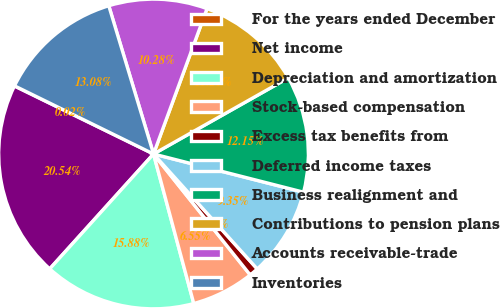Convert chart. <chart><loc_0><loc_0><loc_500><loc_500><pie_chart><fcel>For the years ended December<fcel>Net income<fcel>Depreciation and amortization<fcel>Stock-based compensation<fcel>Excess tax benefits from<fcel>Deferred income taxes<fcel>Business realignment and<fcel>Contributions to pension plans<fcel>Accounts receivable-trade<fcel>Inventories<nl><fcel>0.02%<fcel>20.54%<fcel>15.88%<fcel>6.55%<fcel>0.95%<fcel>9.35%<fcel>12.15%<fcel>11.21%<fcel>10.28%<fcel>13.08%<nl></chart> 